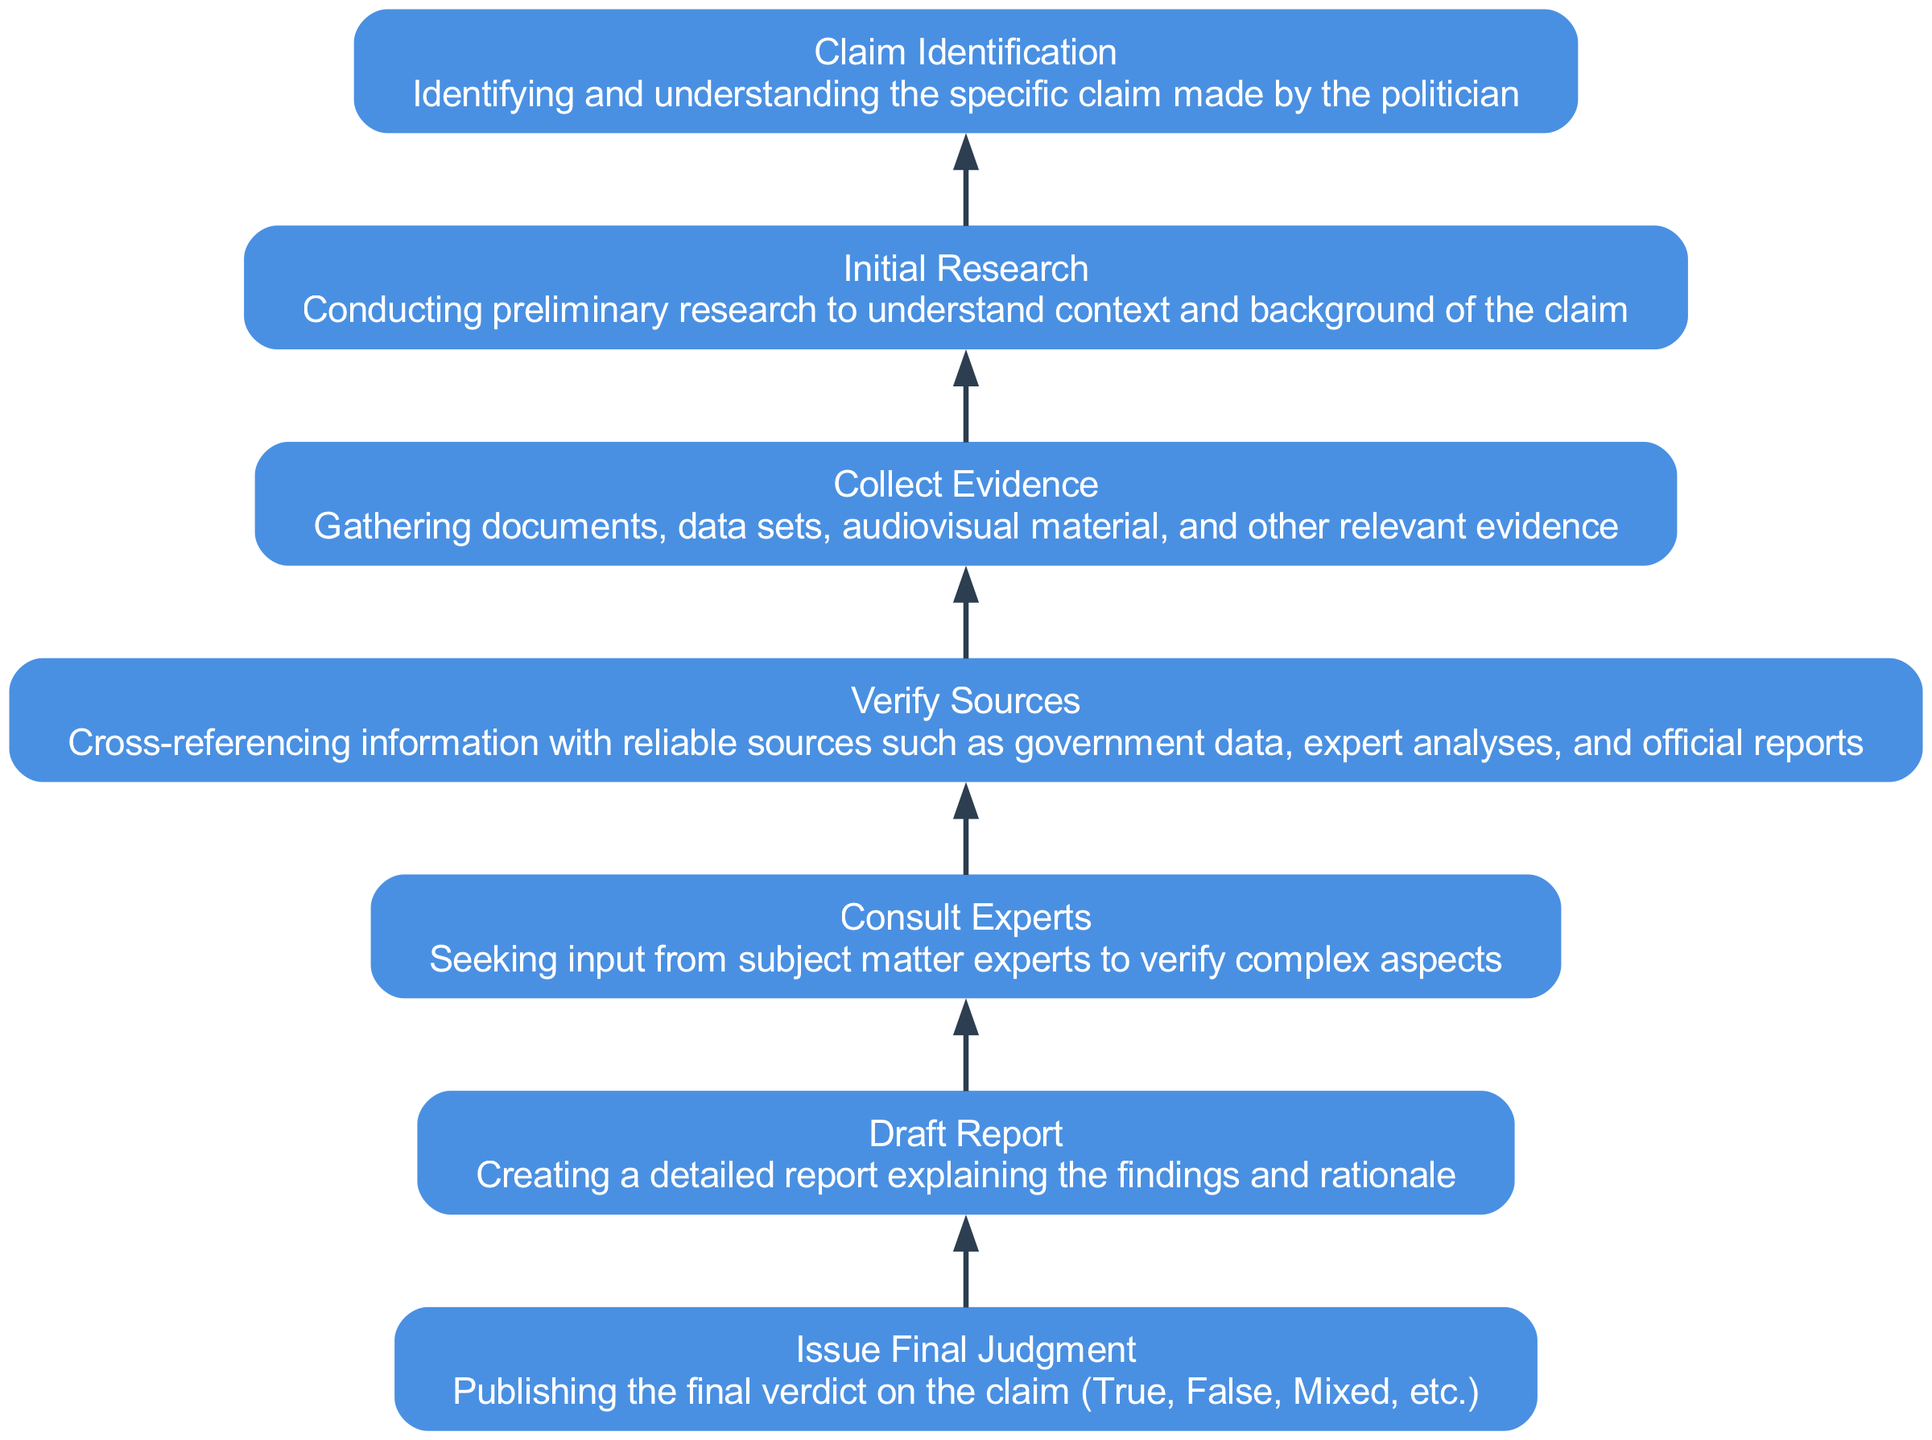What's the top node in the diagram? The top node represents the final output of the flow, which is the last action taken after all preceding steps. In this flow chart, the top node is "Issue Final Judgment."
Answer: Issue Final Judgment How many nodes are there in total? Counting each step in the flow from the initial claim to the final judgment provides the total number of nodes. There are seven nodes in the diagram.
Answer: 7 What is the function of the "Consult Experts" node? The "Consult Experts" node signifies a step in the process where external advice is obtained to enhance the accuracy of the fact-check. It's aligned after verifying sources to deepen the investigation.
Answer: Seeking input from subject matter experts to verify complex aspects Which node precedes "Draft Report"? To determine what comes before "Draft Report," you can trace back the flow from the node in question. Directly preceding "Draft Report" is "Consult Experts."
Answer: Consult Experts What is the relationship between "Collect Evidence" and "Verify Sources"? The relationship between these two nodes is sequential; evidence is gathered first and then verified with reliable sources in the next step. This indicates a logical flow in the fact-checking process.
Answer: Collect Evidence → Verify Sources How does the flow progress after "Initial Research"? The flow progresses from "Initial Research" to the next step of "Collect Evidence", indicating that after gaining context, the collection of relevant evidence follows directly.
Answer: Collect Evidence What judgment could be issued in the final step of the flow? The final step, which is "Issue Final Judgment", could lead to several outcomes based on the findings: True, False, or Mixed. This reflects the possible results of the fact-checking process.
Answer: True, False, Mixed What step occurs just before "Verify Sources"? To find this, trace the flow backwards from "Verify Sources." The step that immediately precedes it is "Collect Evidence." This indicates that evidence must be collected prior to verification.
Answer: Collect Evidence What action is taken before "Issue Final Judgment"? The action taken before issuing the final judgment is the drafting of a report. Therefore, the workflow dictates that after analysis and discussion, a formal report is created as a conclusion.
Answer: Draft Report 